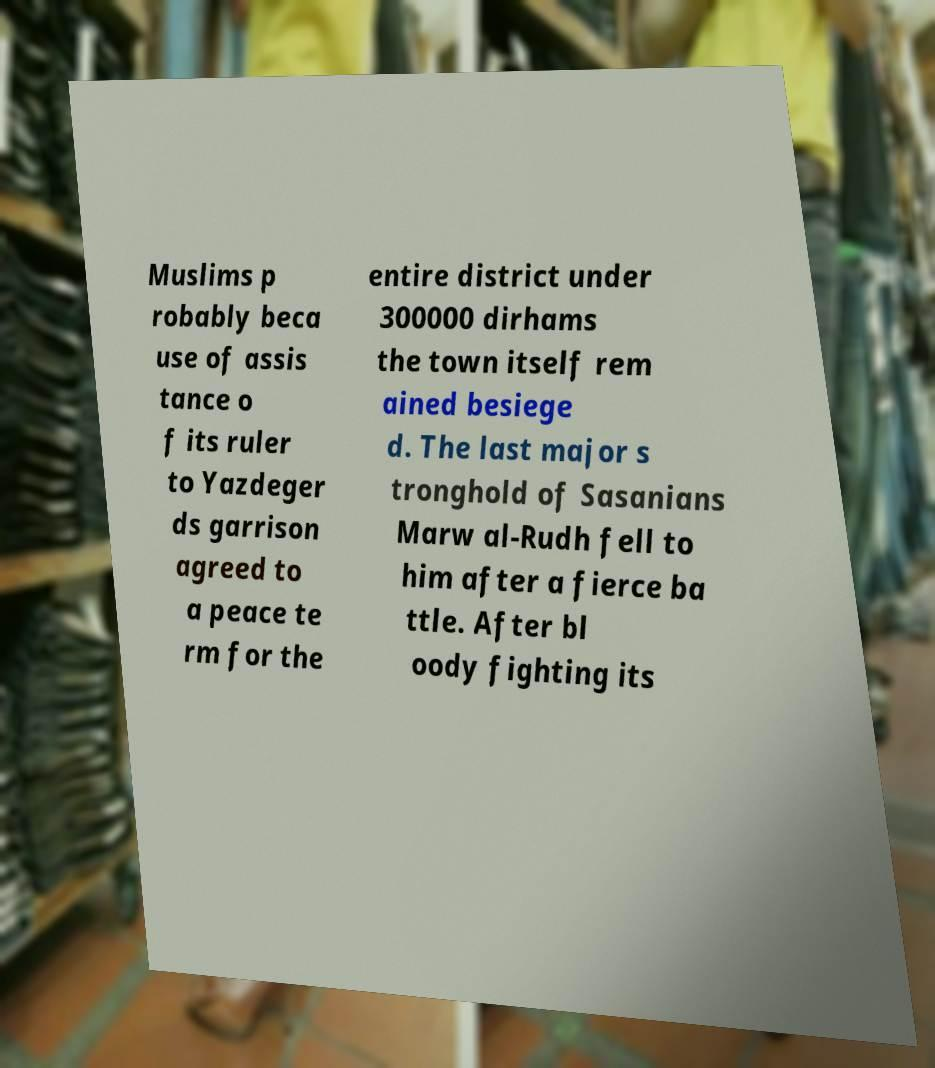Can you accurately transcribe the text from the provided image for me? Muslims p robably beca use of assis tance o f its ruler to Yazdeger ds garrison agreed to a peace te rm for the entire district under 300000 dirhams the town itself rem ained besiege d. The last major s tronghold of Sasanians Marw al-Rudh fell to him after a fierce ba ttle. After bl oody fighting its 